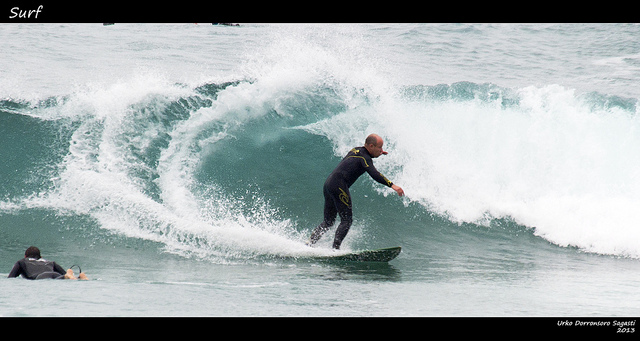Extract all visible text content from this image. Urke 2013 